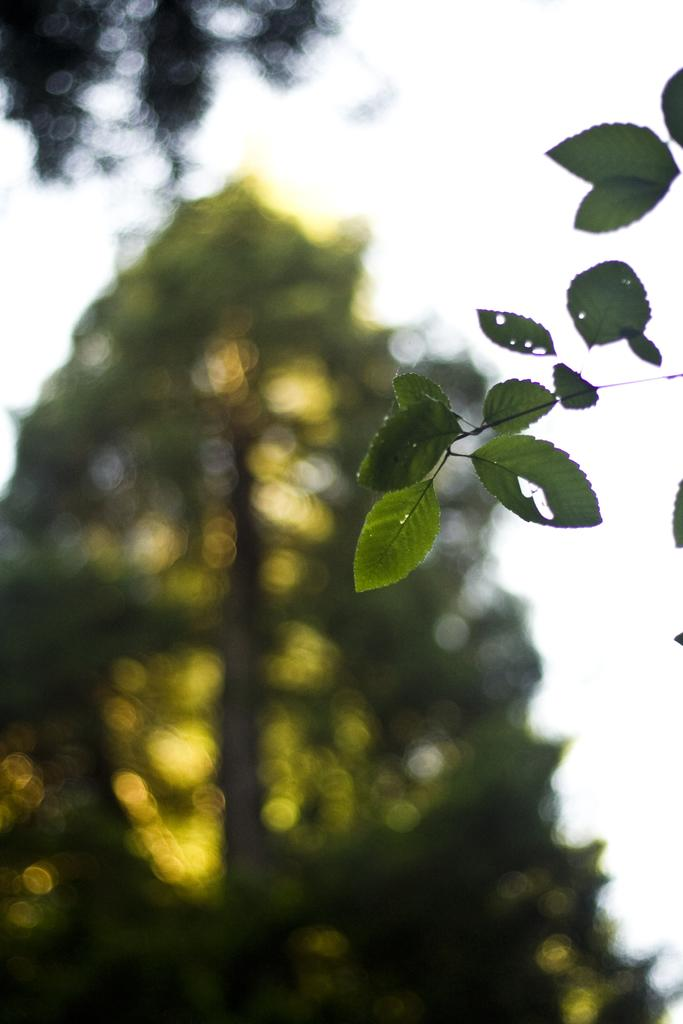What type of vegetation can be seen in the image? There are leaves in the image. What can be seen in the background of the image? There are trees and the sky visible in the background of the image. What pets are mentioned in the caption of the image? There is no caption present in the image, and therefore no pets are mentioned. 